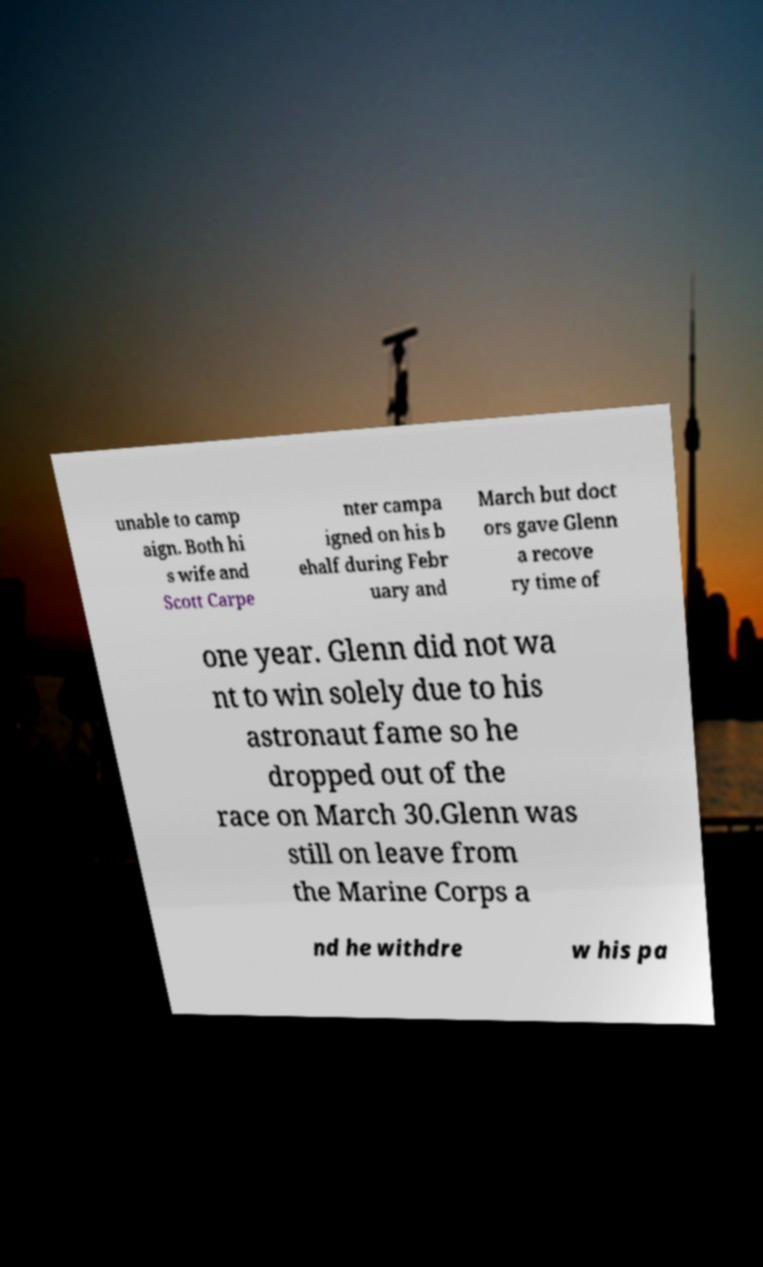I need the written content from this picture converted into text. Can you do that? unable to camp aign. Both hi s wife and Scott Carpe nter campa igned on his b ehalf during Febr uary and March but doct ors gave Glenn a recove ry time of one year. Glenn did not wa nt to win solely due to his astronaut fame so he dropped out of the race on March 30.Glenn was still on leave from the Marine Corps a nd he withdre w his pa 